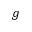<formula> <loc_0><loc_0><loc_500><loc_500>g</formula> 